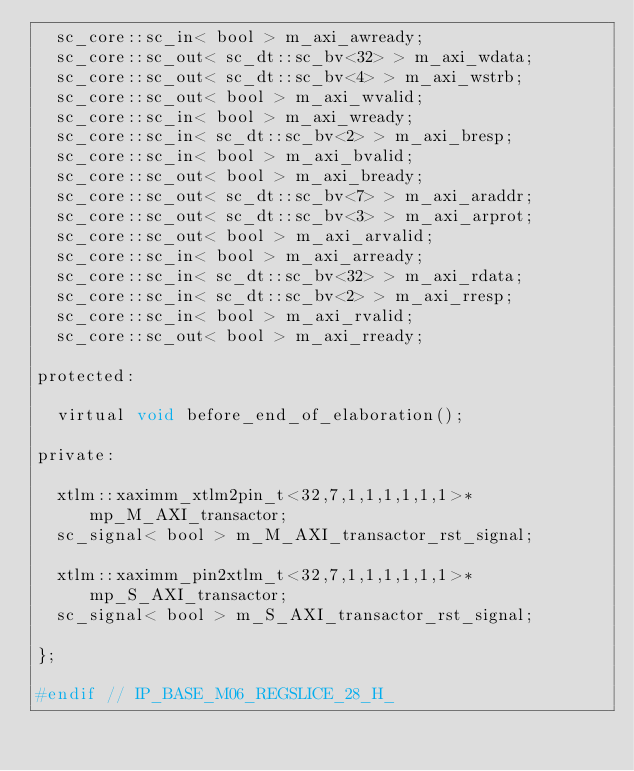<code> <loc_0><loc_0><loc_500><loc_500><_C_>  sc_core::sc_in< bool > m_axi_awready;
  sc_core::sc_out< sc_dt::sc_bv<32> > m_axi_wdata;
  sc_core::sc_out< sc_dt::sc_bv<4> > m_axi_wstrb;
  sc_core::sc_out< bool > m_axi_wvalid;
  sc_core::sc_in< bool > m_axi_wready;
  sc_core::sc_in< sc_dt::sc_bv<2> > m_axi_bresp;
  sc_core::sc_in< bool > m_axi_bvalid;
  sc_core::sc_out< bool > m_axi_bready;
  sc_core::sc_out< sc_dt::sc_bv<7> > m_axi_araddr;
  sc_core::sc_out< sc_dt::sc_bv<3> > m_axi_arprot;
  sc_core::sc_out< bool > m_axi_arvalid;
  sc_core::sc_in< bool > m_axi_arready;
  sc_core::sc_in< sc_dt::sc_bv<32> > m_axi_rdata;
  sc_core::sc_in< sc_dt::sc_bv<2> > m_axi_rresp;
  sc_core::sc_in< bool > m_axi_rvalid;
  sc_core::sc_out< bool > m_axi_rready;

protected:

  virtual void before_end_of_elaboration();

private:

  xtlm::xaximm_xtlm2pin_t<32,7,1,1,1,1,1,1>* mp_M_AXI_transactor;
  sc_signal< bool > m_M_AXI_transactor_rst_signal;

  xtlm::xaximm_pin2xtlm_t<32,7,1,1,1,1,1,1>* mp_S_AXI_transactor;
  sc_signal< bool > m_S_AXI_transactor_rst_signal;

};

#endif // IP_BASE_M06_REGSLICE_28_H_
</code> 